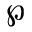Convert formula to latex. <formula><loc_0><loc_0><loc_500><loc_500>\wp</formula> 